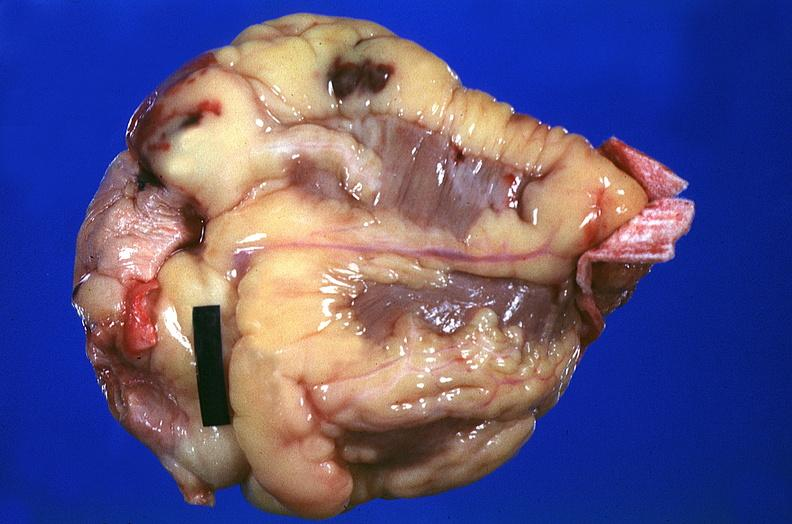what is present?
Answer the question using a single word or phrase. Cardiovascular 